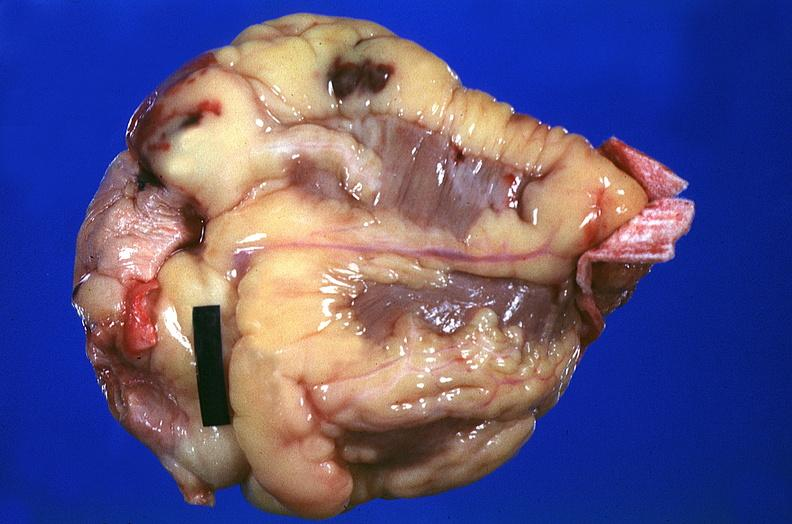what is present?
Answer the question using a single word or phrase. Cardiovascular 